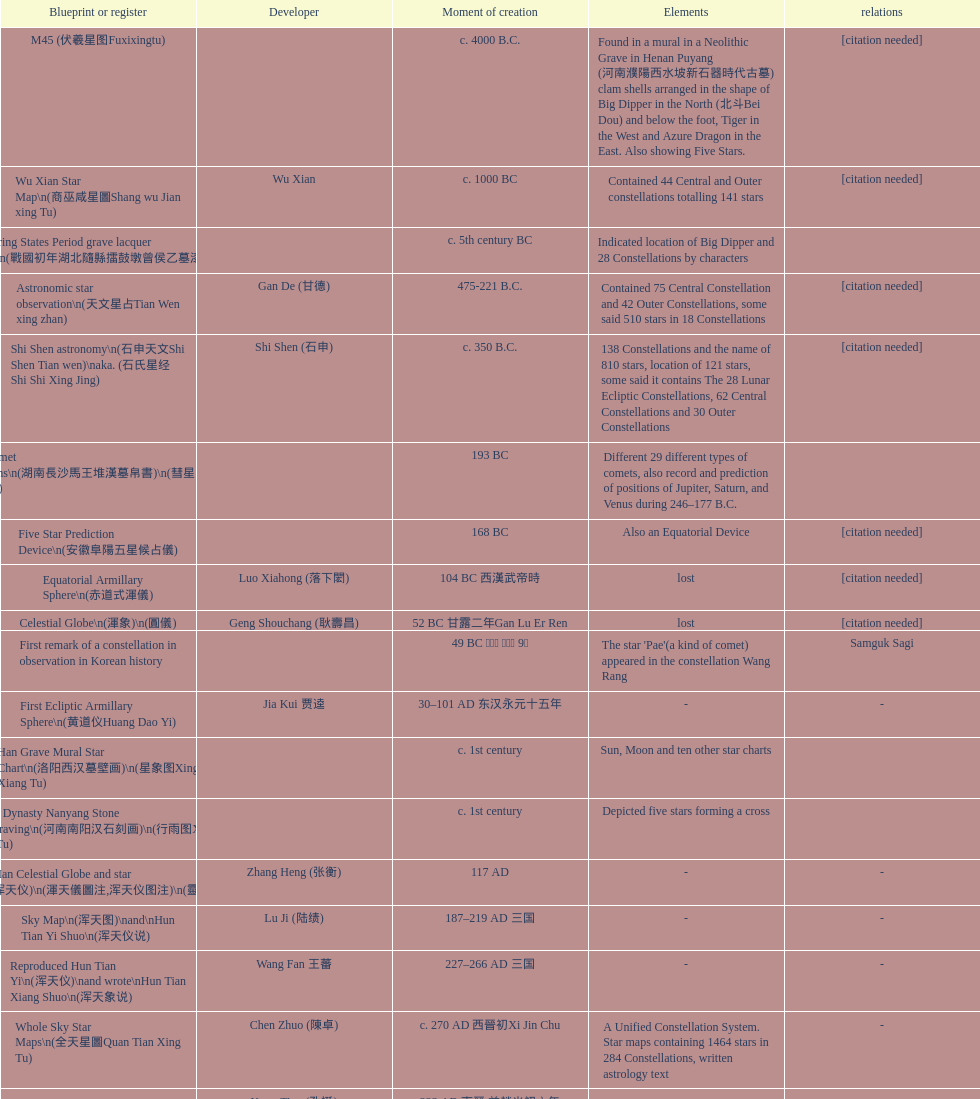List three inventions that emerged soon after the equatorial armillary sphere. Celestial Globe (渾象) (圓儀), First remark of a constellation in observation in Korean history, First Ecliptic Armillary Sphere (黄道仪Huang Dao Yi). 